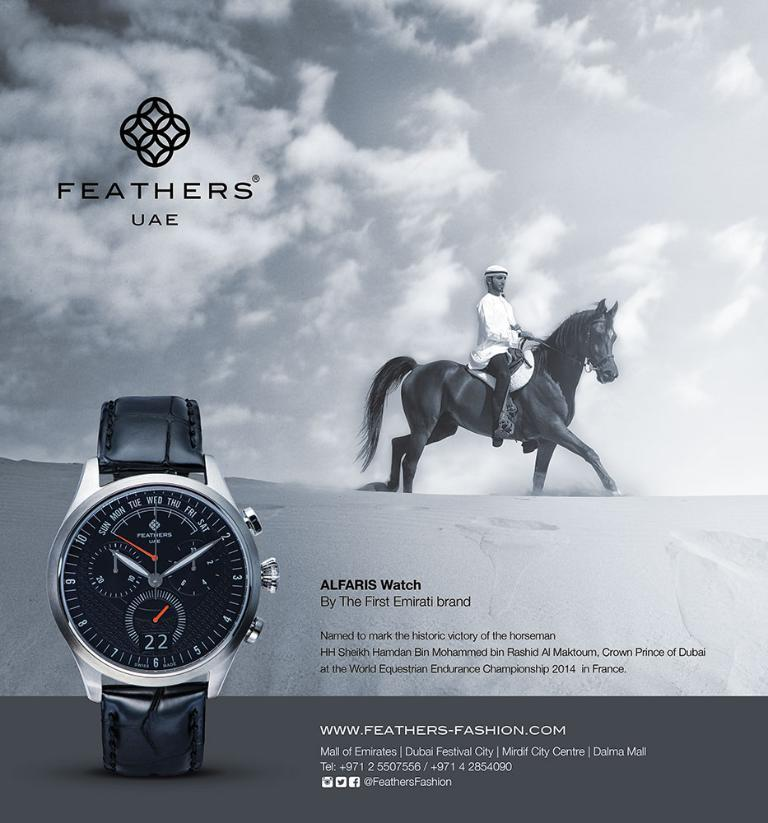<image>
Describe the image concisely. Alfaris watch by the first emirati brand feathers uae 